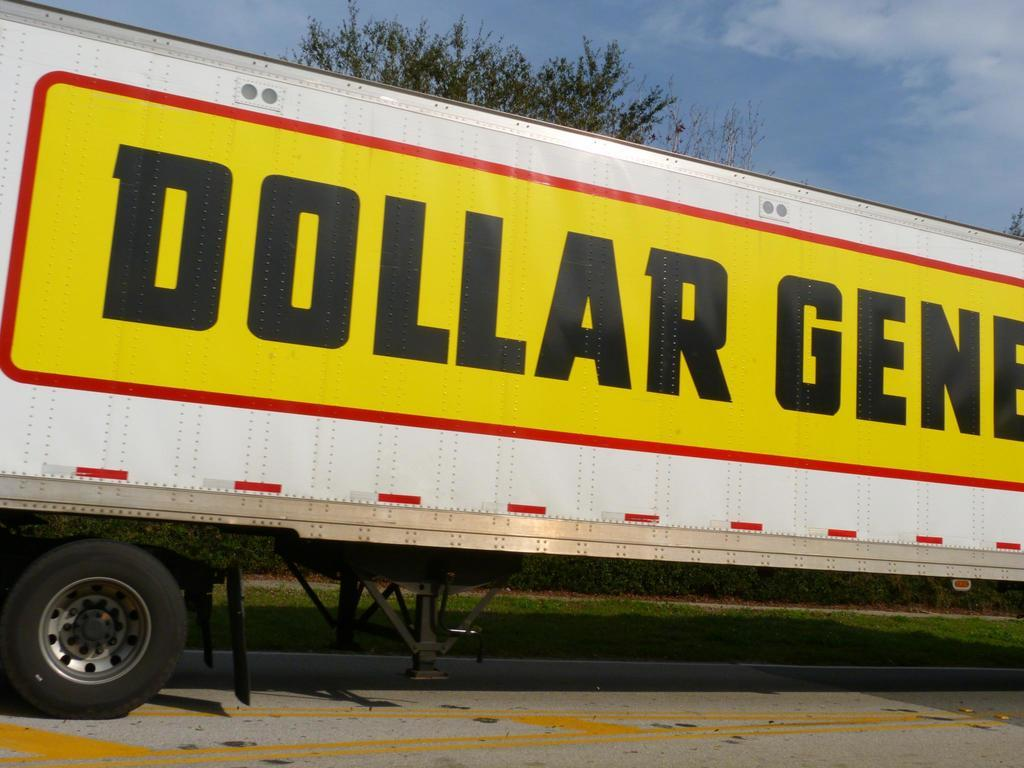What type of vehicle is on the road in the image? There is a truck on the road in the image. What can be seen in the background of the image? There is grass, trees, and a blue sky in the background of the image. What type of blade is being used in the war depicted in the image? There is no war or blade present in the image; it features a truck on the road with a grassy and tree-filled background. 